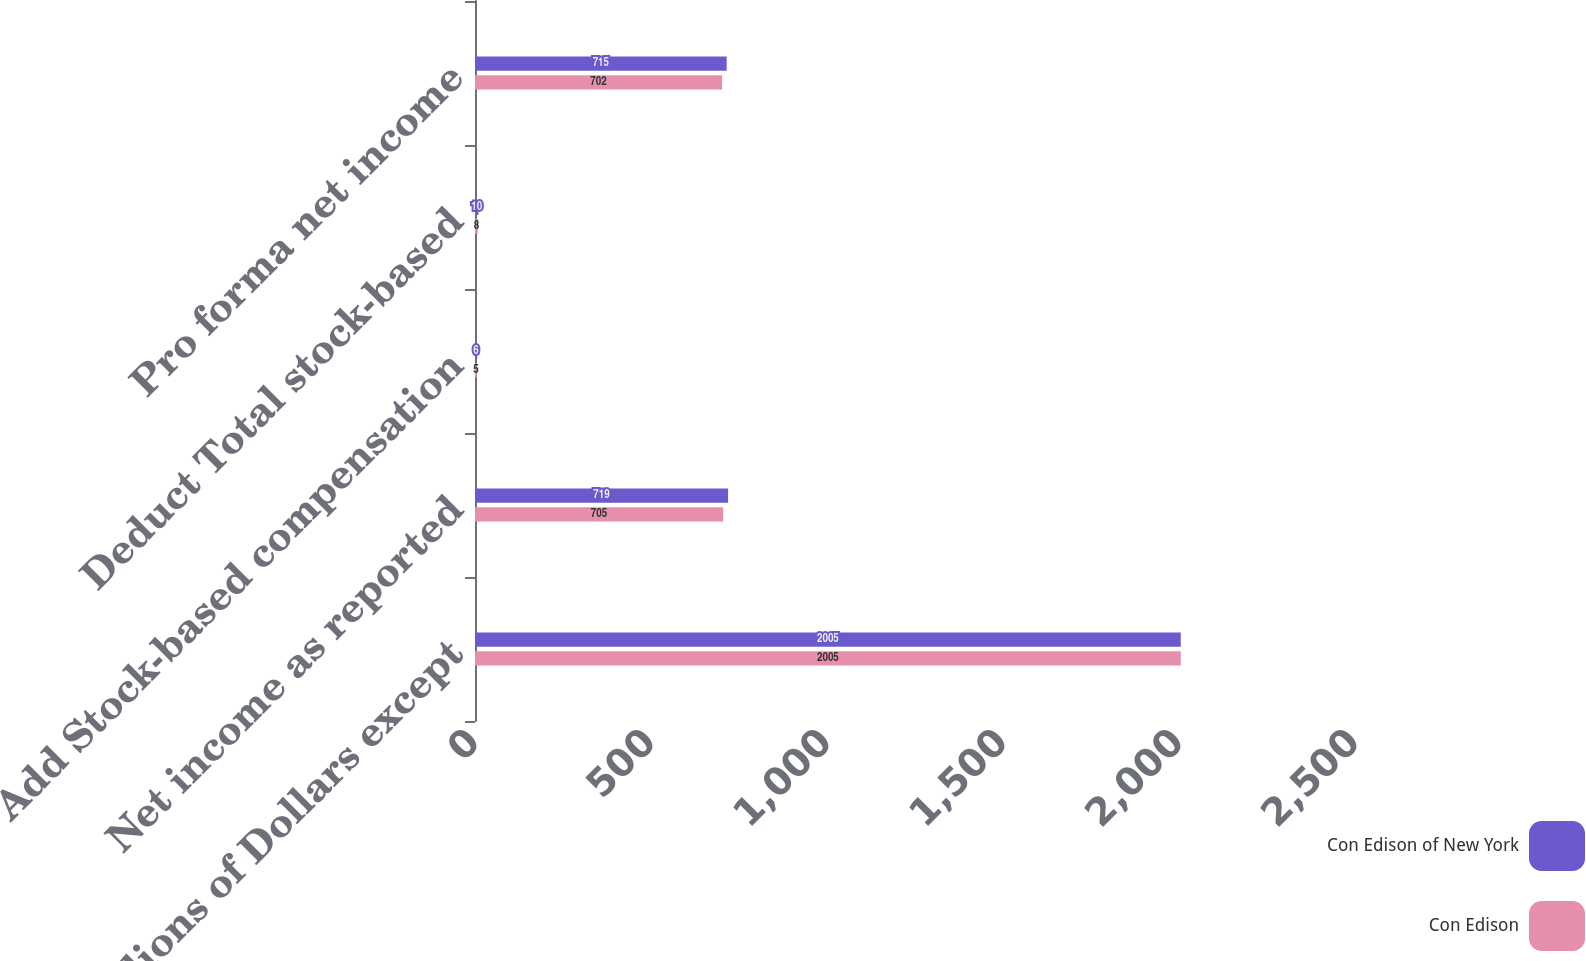Convert chart. <chart><loc_0><loc_0><loc_500><loc_500><stacked_bar_chart><ecel><fcel>(Millions of Dollars except<fcel>Net income as reported<fcel>Add Stock-based compensation<fcel>Deduct Total stock-based<fcel>Pro forma net income<nl><fcel>Con Edison of New York<fcel>2005<fcel>719<fcel>6<fcel>10<fcel>715<nl><fcel>Con Edison<fcel>2005<fcel>705<fcel>5<fcel>8<fcel>702<nl></chart> 